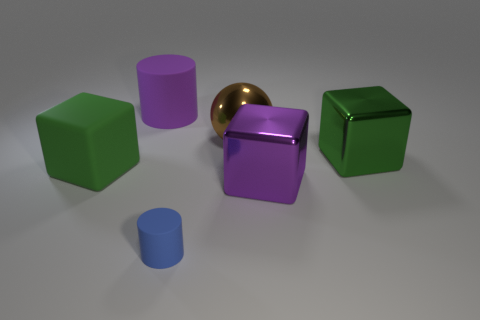Add 1 gray cylinders. How many objects exist? 7 Subtract all big cylinders. Subtract all purple metal objects. How many objects are left? 4 Add 6 large green blocks. How many large green blocks are left? 8 Add 6 large balls. How many large balls exist? 7 Subtract all purple cylinders. How many cylinders are left? 1 Subtract all big green rubber cubes. How many cubes are left? 2 Subtract 0 red cylinders. How many objects are left? 6 Subtract all cylinders. How many objects are left? 4 Subtract 1 balls. How many balls are left? 0 Subtract all cyan blocks. Subtract all purple balls. How many blocks are left? 3 